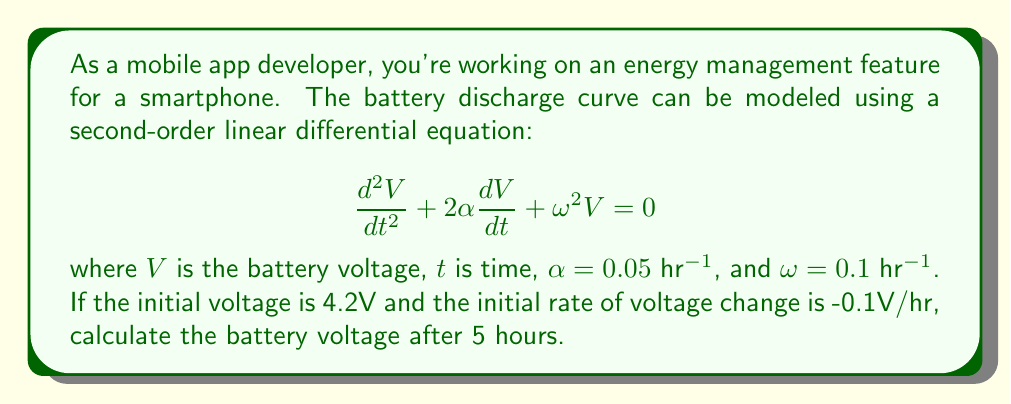Teach me how to tackle this problem. To solve this problem, we need to follow these steps:

1) The general solution for this second-order linear differential equation is:

   $$V(t) = e^{-\alpha t}(A\cos(\beta t) + B\sin(\beta t))$$

   where $\beta = \sqrt{\omega^2 - \alpha^2}$

2) Calculate $\beta$:
   $$\beta = \sqrt{0.1^2 - 0.05^2} = \sqrt{0.01 - 0.0025} = \sqrt{0.0075} \approx 0.0866$$

3) Use the initial conditions to find $A$ and $B$:
   - $V(0) = 4.2$, so $A = 4.2$
   - $V'(t) = -\alpha e^{-\alpha t}(A\cos(\beta t) + B\sin(\beta t)) + e^{-\alpha t}(-A\beta\sin(\beta t) + B\beta\cos(\beta t))$
   - $V'(0) = -0.1 = -\alpha A + B\beta$
   - $-0.1 = -0.05(4.2) + 0.0866B$
   - $B \approx 0.8646$

4) The solution is:
   $$V(t) = e^{-0.05t}(4.2\cos(0.0866t) + 0.8646\sin(0.0866t))$$

5) Calculate $V(5)$:
   $$V(5) = e^{-0.05(5)}(4.2\cos(0.0866(5)) + 0.8646\sin(0.0866(5)))$$
   $$= 0.7788(4.2(0.8145) + 0.8646(0.5802))$$
   $$= 0.7788(3.4209 + 0.5016)$$
   $$= 0.7788(3.9225)$$
   $$= 3.0551$$
Answer: The battery voltage after 5 hours is approximately 3.06V. 